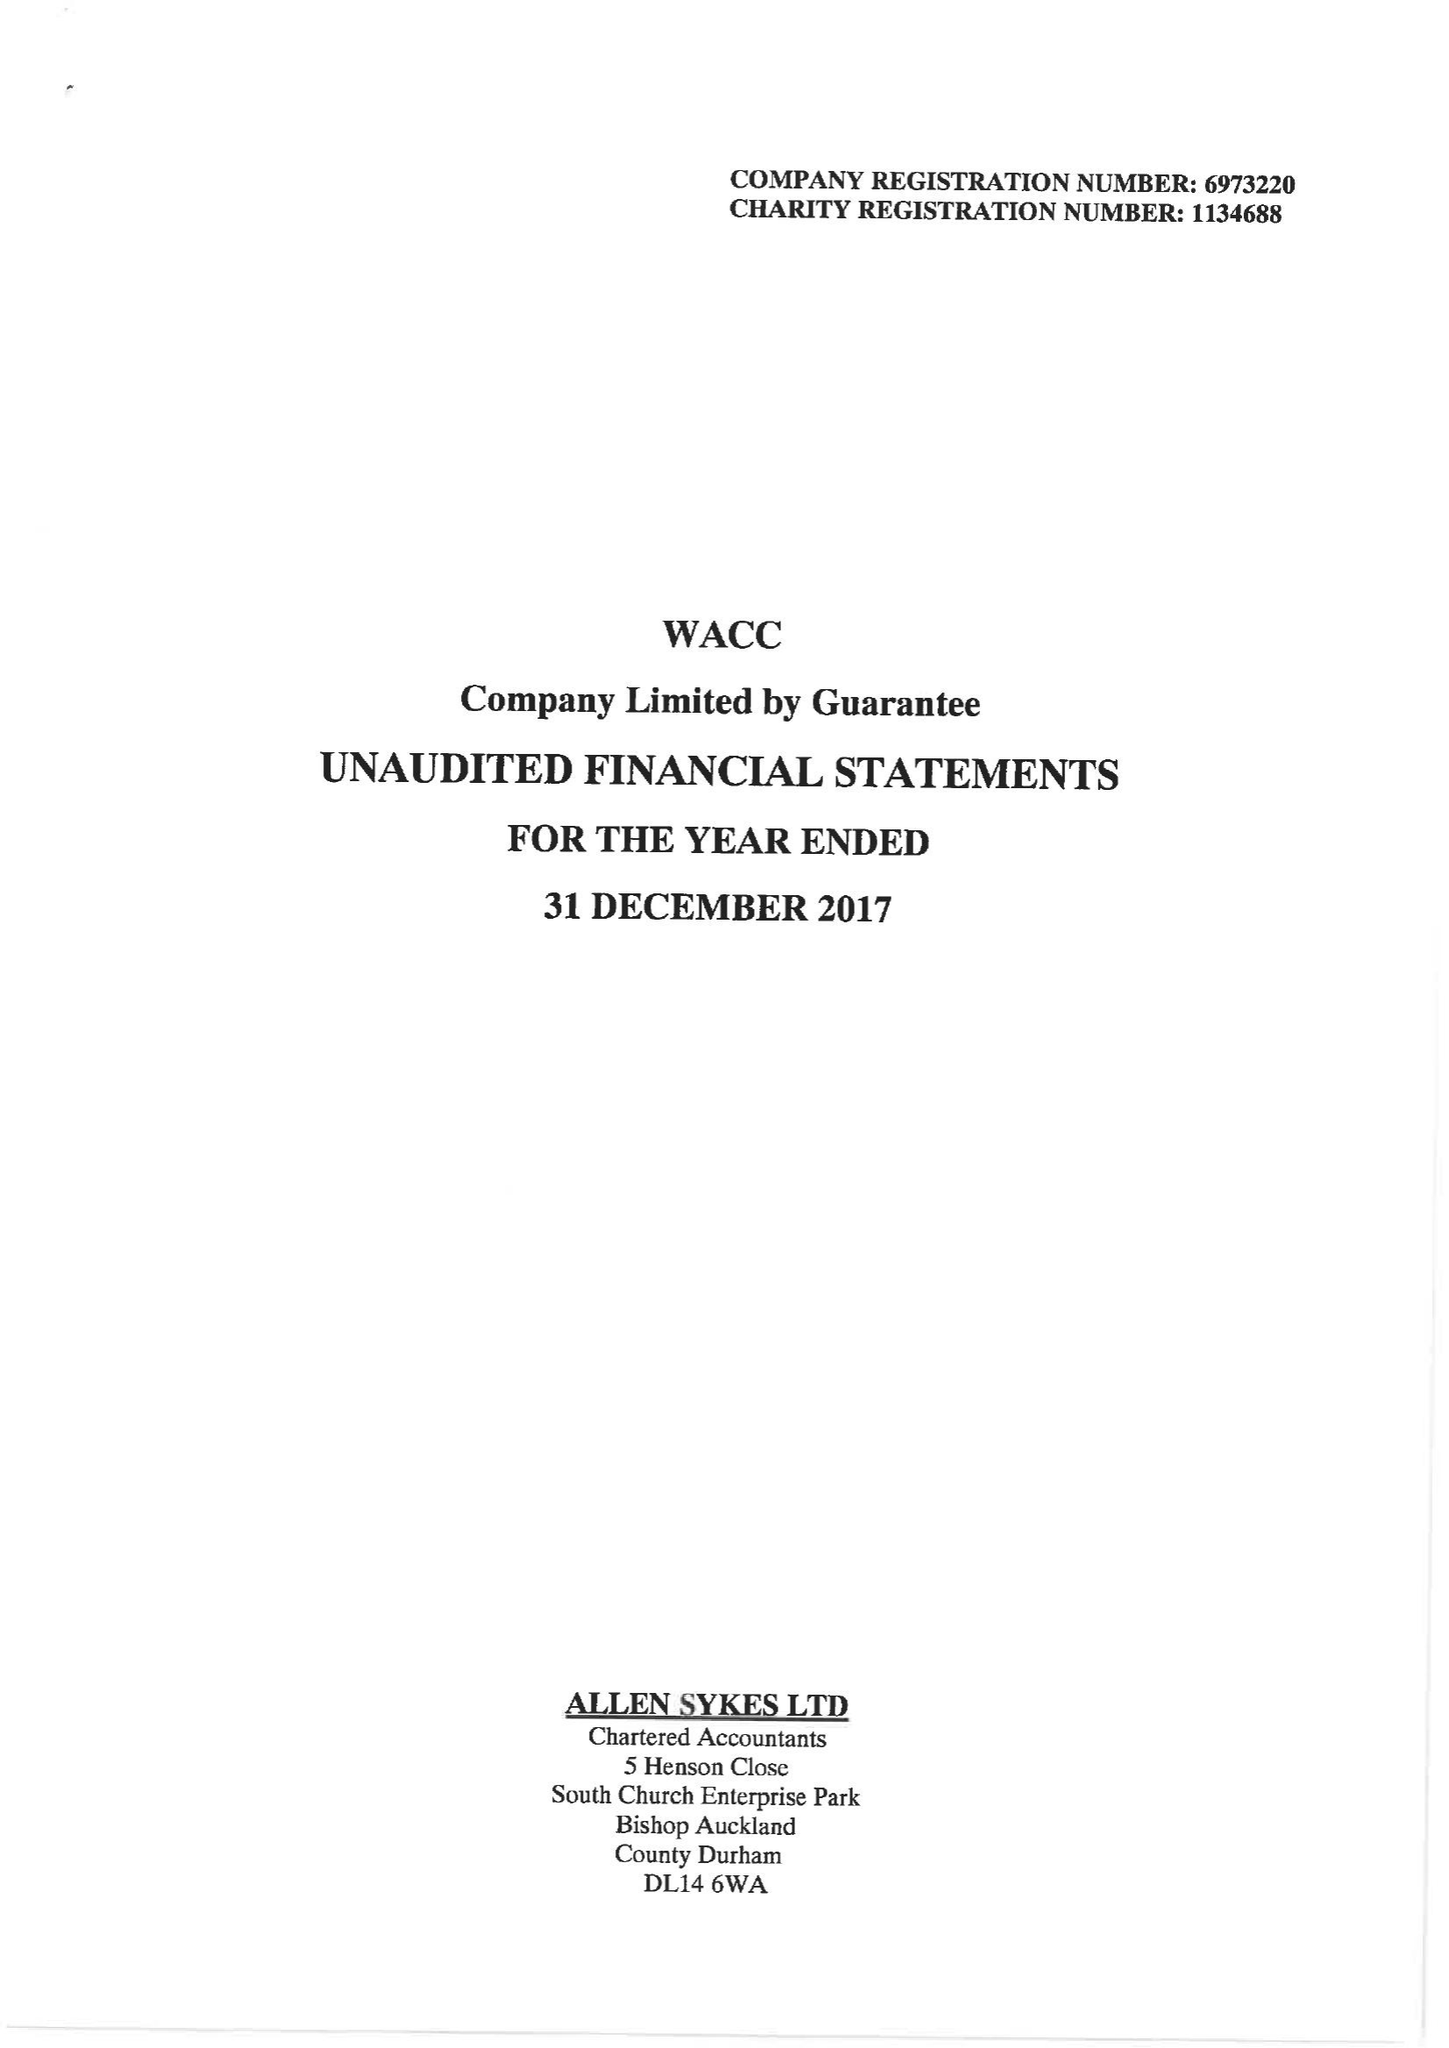What is the value for the address__street_line?
Answer the question using a single word or phrase. None 